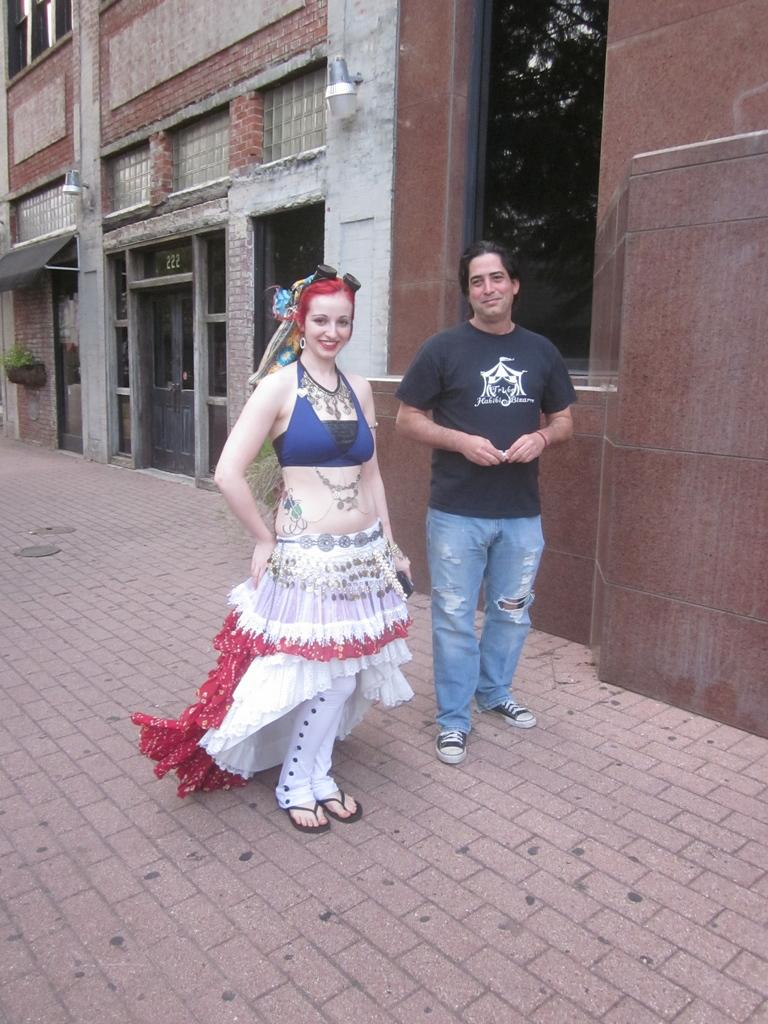How many people are in the image? There are two people in the image. What are the people wearing? The people are wearing different color dresses. What expression do the people have? The people are smiling. What can be seen in the background of the image? There is a building in the image. What colors are present on the building? The building has brown and ash colors. What type of balls are being used for learning in the image? There are no balls or learning activities present in the image. Can you tell me how many pears are visible in the image? There are no pears visible in the image. 